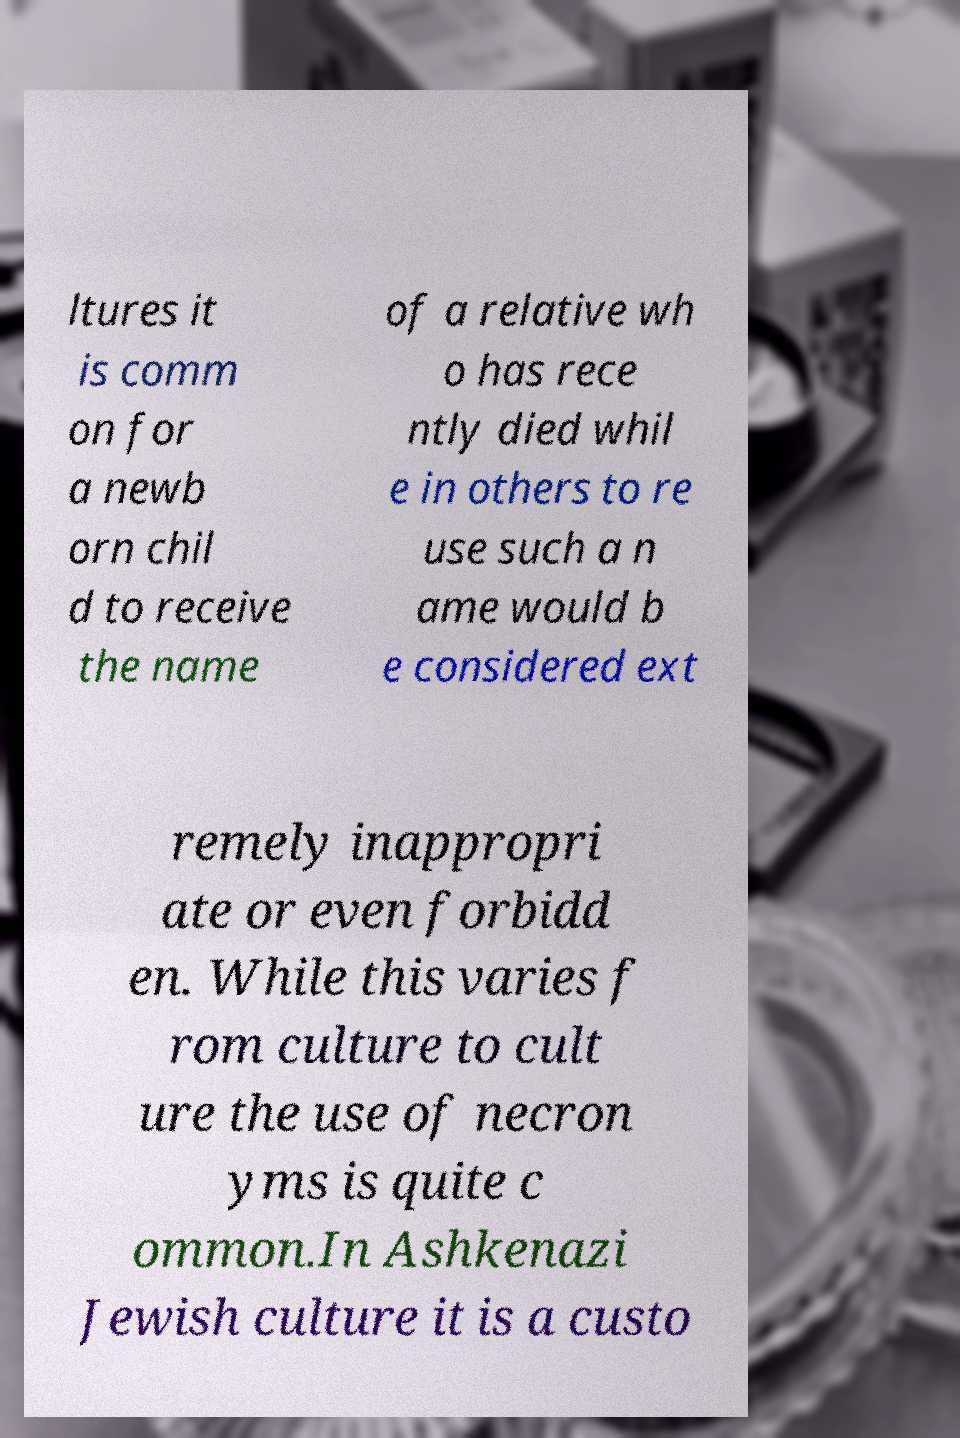Can you accurately transcribe the text from the provided image for me? ltures it is comm on for a newb orn chil d to receive the name of a relative wh o has rece ntly died whil e in others to re use such a n ame would b e considered ext remely inappropri ate or even forbidd en. While this varies f rom culture to cult ure the use of necron yms is quite c ommon.In Ashkenazi Jewish culture it is a custo 